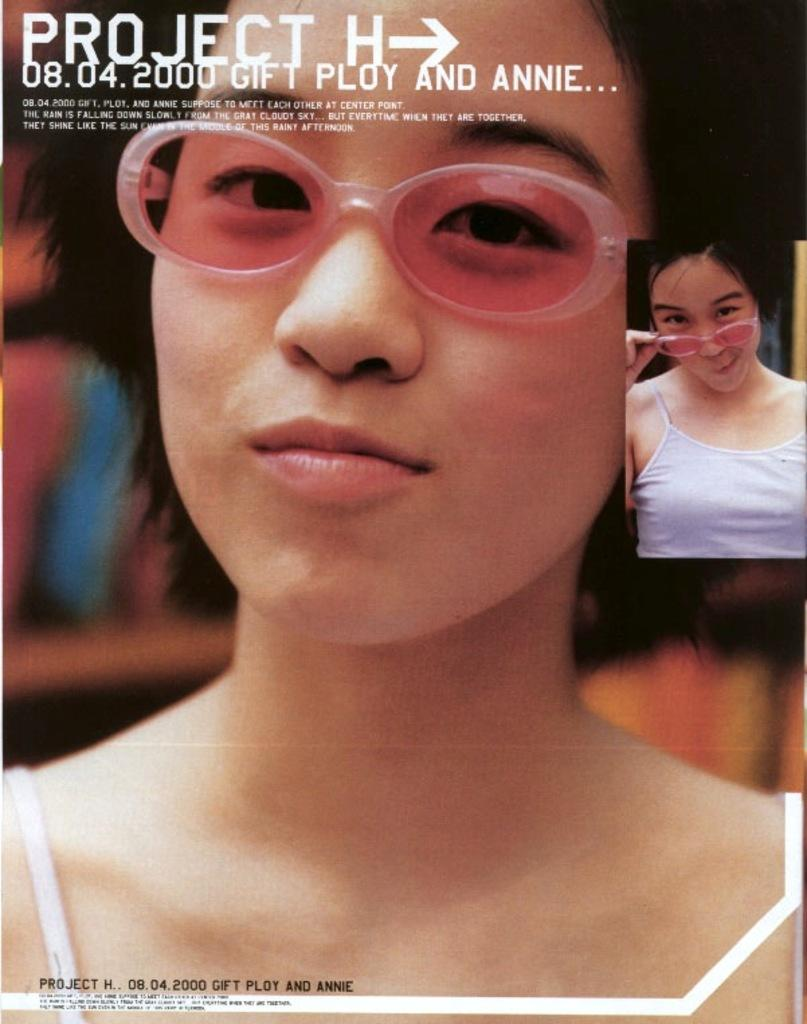What is a common feature shared by the two women in the image? Both women are wearing spectacles in the image. Where is the second woman located in relation to the first woman? The second woman is on the left side of the image. What can be observed about the background of the image? The background of the image is blurred. What is present at the top of the image? There is text visible at the top of the image. What type of mark does the woman on the right make on the paper in the image? There is no woman on the right in the image, and no paper or mark-making activity is depicted. 